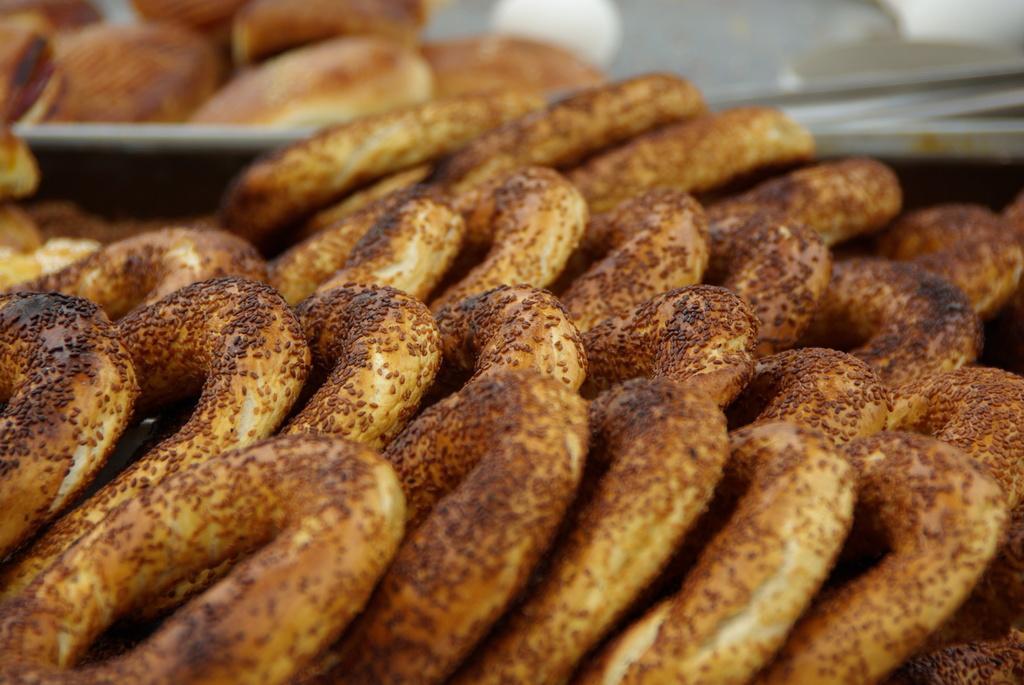Could you give a brief overview of what you see in this image? In this image we can see snacks and there is a plate. 